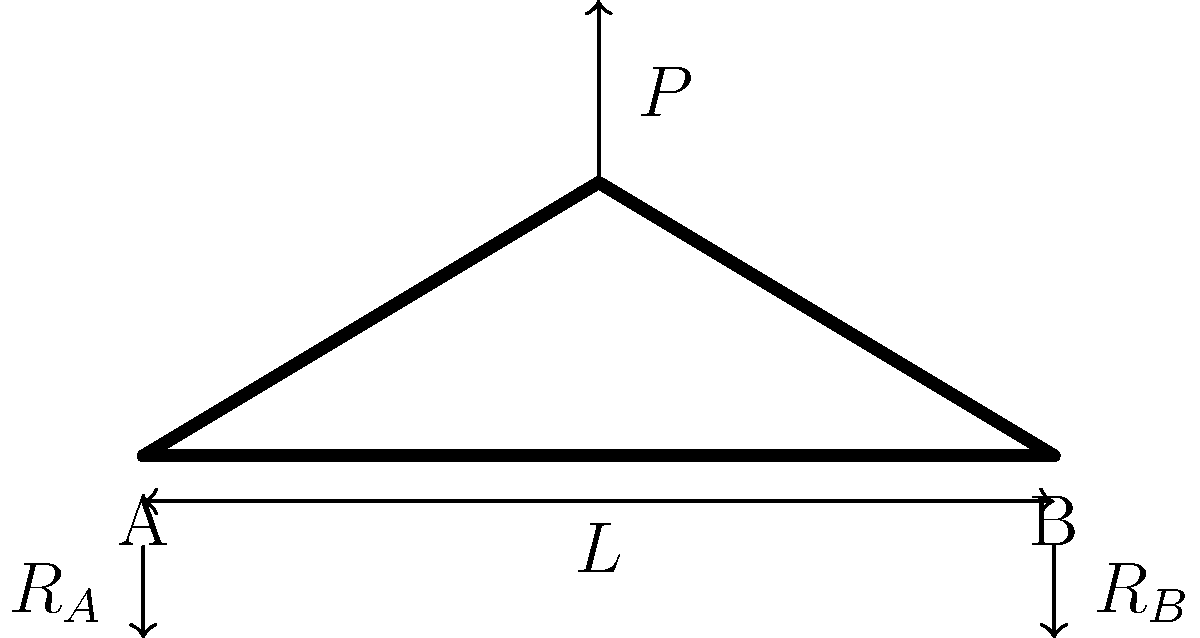A simply supported bridge has a span length $L$ of 50 meters and is subjected to a concentrated load $P$ of 1000 kN at its midpoint. The bridge's main structural element is a steel truss with a yield strength of 350 MPa. If the maximum allowable stress in the truss members is limited to 60% of the yield strength, what is the minimum required cross-sectional area of the most heavily loaded vertical member at the midpoint of the bridge? To solve this problem, we'll follow these steps:

1) First, calculate the reaction forces at the supports:
   Due to symmetry, $R_A = R_B = P/2 = 1000/2 = 500$ kN

2) The maximum internal force in the vertical member at the midpoint will be equal to the reaction force:
   $F_{max} = 500$ kN

3) Calculate the allowable stress:
   $\sigma_{allow} = 0.60 \times \sigma_{yield} = 0.60 \times 350 = 210$ MPa

4) Use the stress formula to determine the required area:
   $$\sigma = \frac{F}{A}$$
   where $\sigma$ is stress, $F$ is force, and $A$ is area.

5) Rearrange the formula to solve for area:
   $$A = \frac{F}{\sigma_{allow}}$$

6) Substitute the values:
   $$A = \frac{500 \times 10^3 \text{ N}}{210 \times 10^6 \text{ Pa}} = 2.38 \times 10^{-3} \text{ m}^2 = 2380 \text{ mm}^2$$

Therefore, the minimum required cross-sectional area of the most heavily loaded vertical member is 2380 mm².
Answer: 2380 mm² 